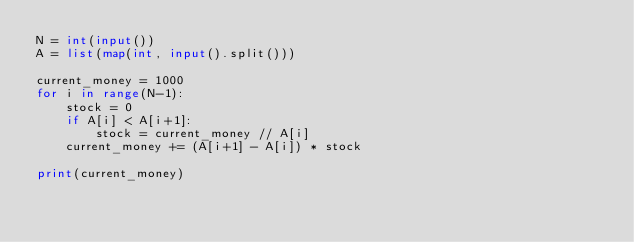Convert code to text. <code><loc_0><loc_0><loc_500><loc_500><_Python_>N = int(input())
A = list(map(int, input().split()))

current_money = 1000
for i in range(N-1):
    stock = 0
    if A[i] < A[i+1]:
        stock = current_money // A[i]
    current_money += (A[i+1] - A[i]) * stock

print(current_money)
</code> 